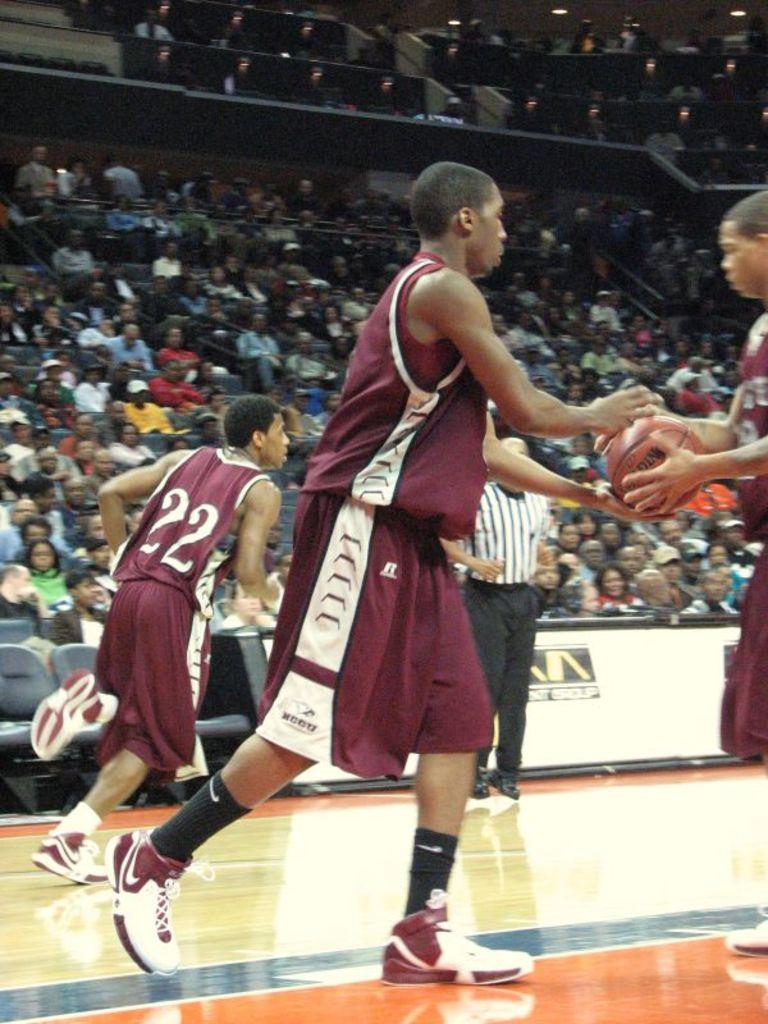What type of venue is shown in the image? There is a basketball stadium in the image. How many people are present in the stadium? There are many people sitting in the stadium. What are the people doing in the image? The people are watching a game. What can be seen on the court in the image? The basketball court is visible in the image, and players are present on the court. Where is the oven located in the image? There is no oven present in the image. What type of paper is being used by the players on the court? There is no paper visible in the image; the players are playing basketball on the court. 